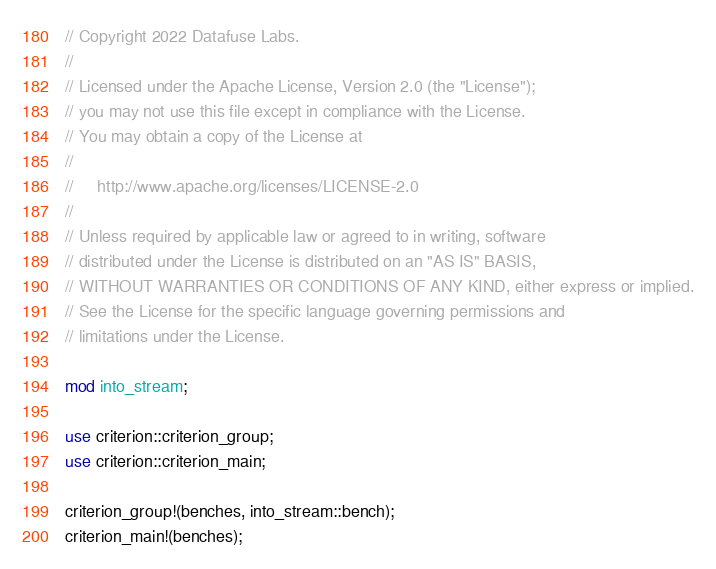<code> <loc_0><loc_0><loc_500><loc_500><_Rust_>// Copyright 2022 Datafuse Labs.
//
// Licensed under the Apache License, Version 2.0 (the "License");
// you may not use this file except in compliance with the License.
// You may obtain a copy of the License at
//
//     http://www.apache.org/licenses/LICENSE-2.0
//
// Unless required by applicable law or agreed to in writing, software
// distributed under the License is distributed on an "AS IS" BASIS,
// WITHOUT WARRANTIES OR CONDITIONS OF ANY KIND, either express or implied.
// See the License for the specific language governing permissions and
// limitations under the License.

mod into_stream;

use criterion::criterion_group;
use criterion::criterion_main;

criterion_group!(benches, into_stream::bench);
criterion_main!(benches);
</code> 